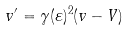Convert formula to latex. <formula><loc_0><loc_0><loc_500><loc_500>v ^ { \prime } = \gamma ( \varepsilon ) ^ { 2 } ( v - V )</formula> 